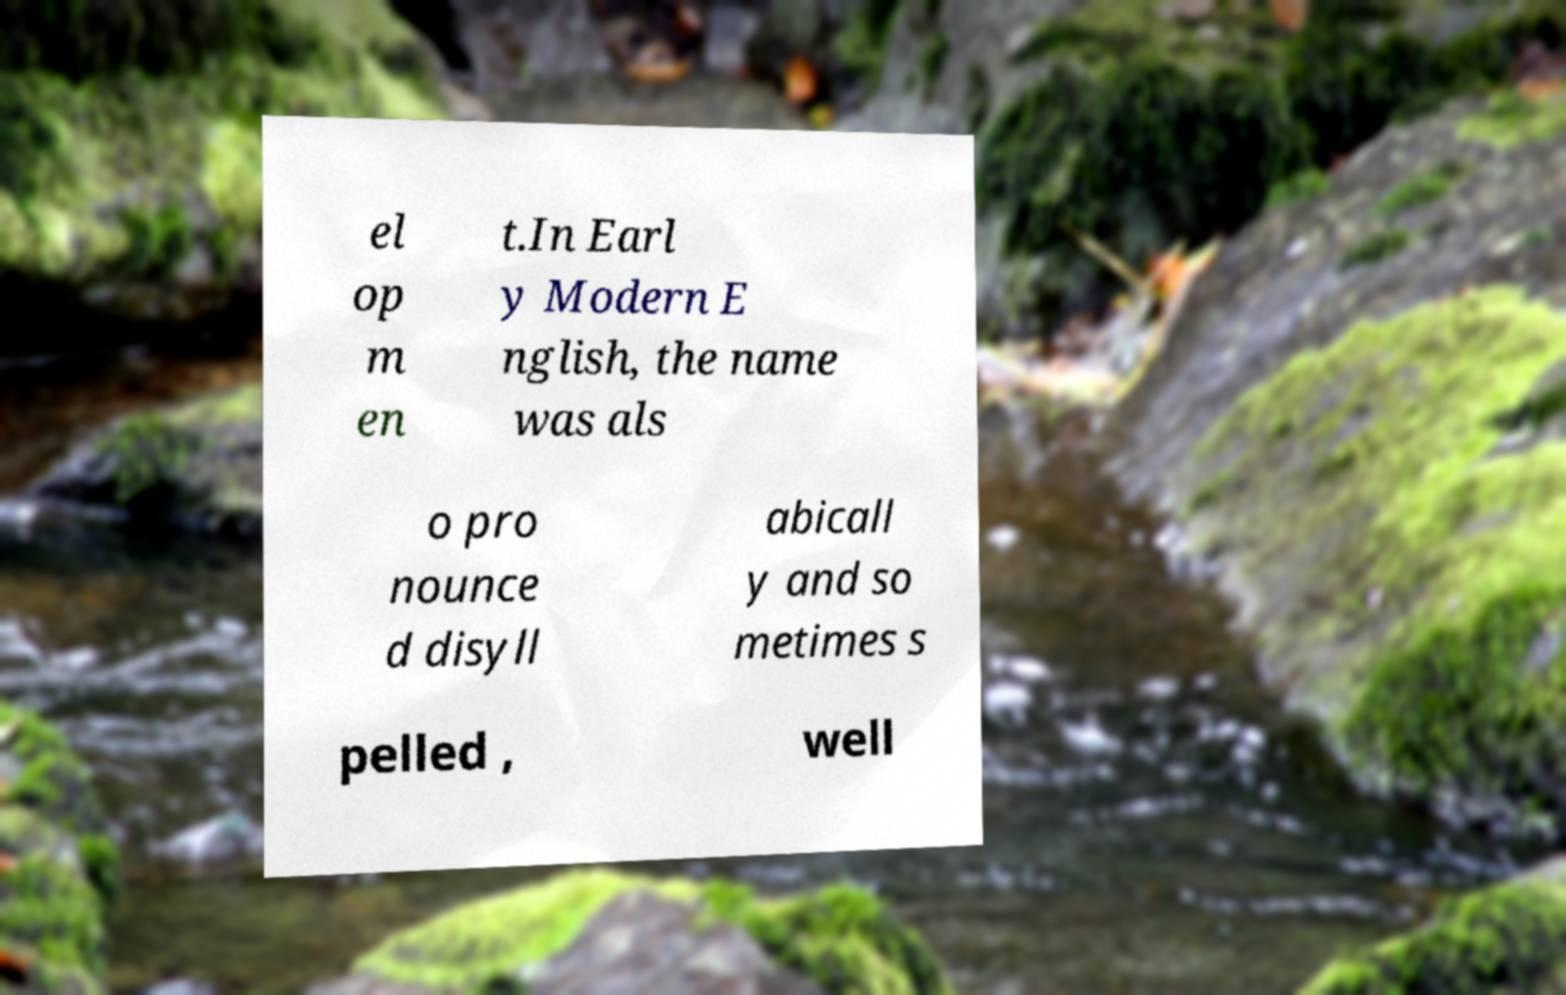Could you extract and type out the text from this image? el op m en t.In Earl y Modern E nglish, the name was als o pro nounce d disyll abicall y and so metimes s pelled , well 